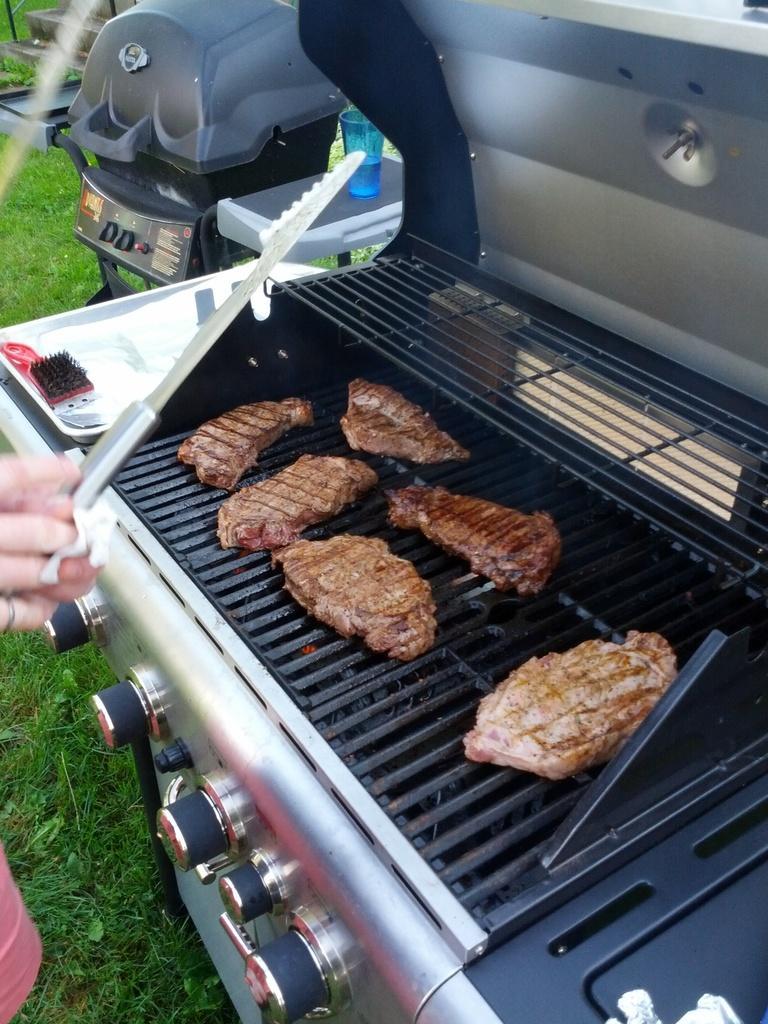In one or two sentences, can you explain what this image depicts? In this image on the right side there is one stove, on the stove there are some food items and on the left side there is one person. And at the bottom there is grass, in the background there are some other objects. 